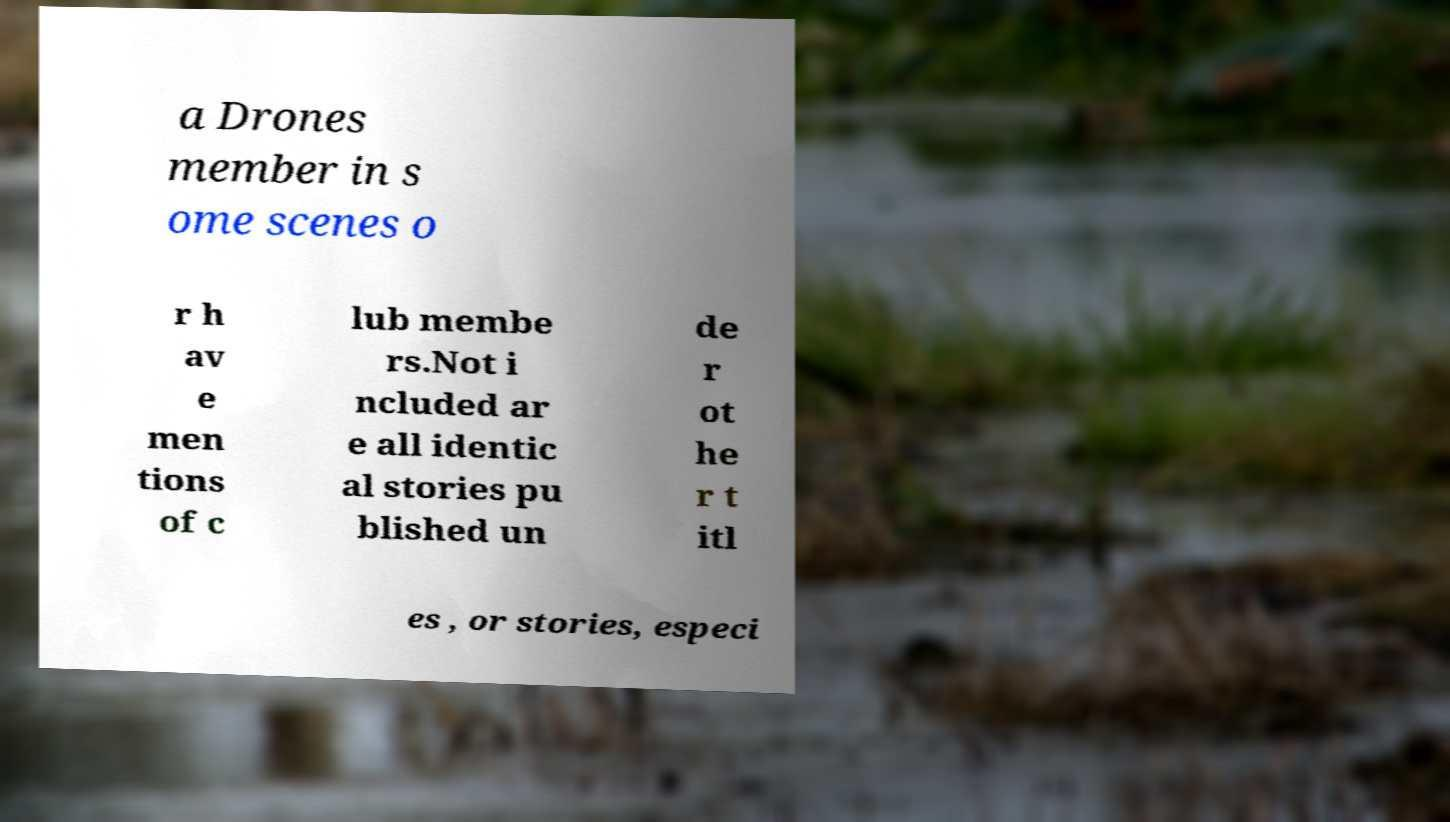Please identify and transcribe the text found in this image. a Drones member in s ome scenes o r h av e men tions of c lub membe rs.Not i ncluded ar e all identic al stories pu blished un de r ot he r t itl es , or stories, especi 